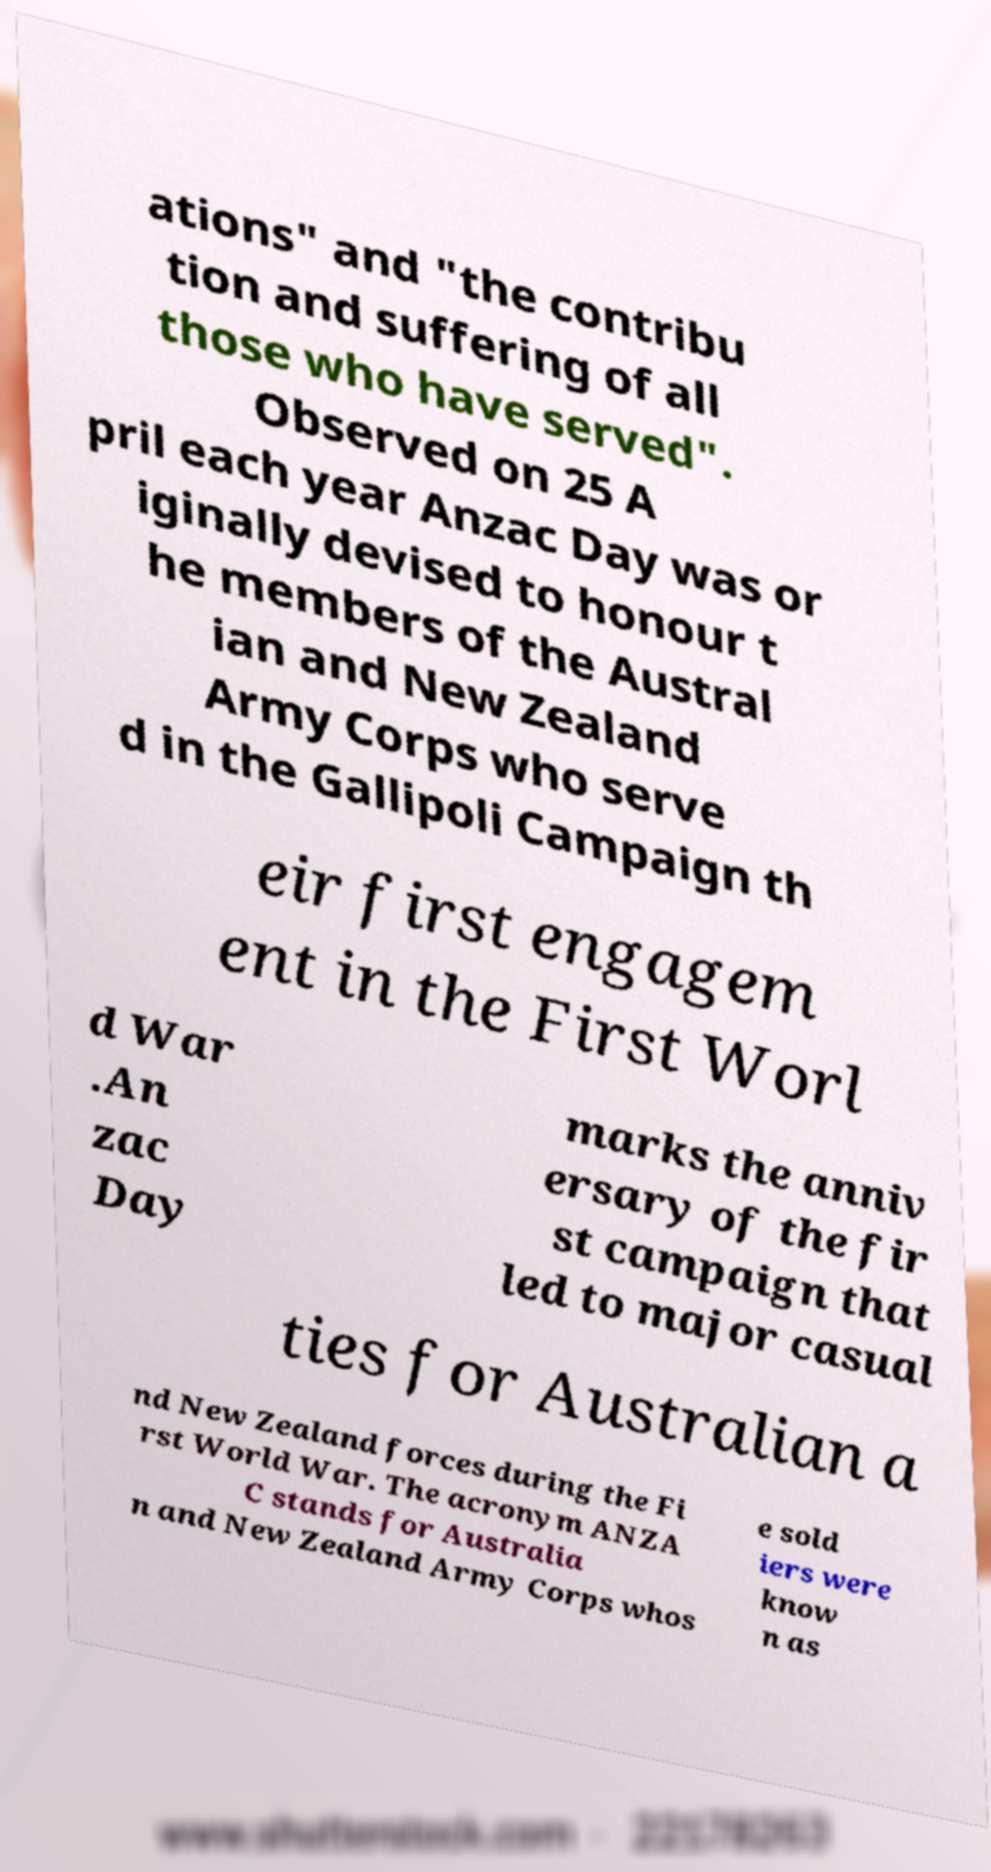What messages or text are displayed in this image? I need them in a readable, typed format. ations" and "the contribu tion and suffering of all those who have served". Observed on 25 A pril each year Anzac Day was or iginally devised to honour t he members of the Austral ian and New Zealand Army Corps who serve d in the Gallipoli Campaign th eir first engagem ent in the First Worl d War .An zac Day marks the anniv ersary of the fir st campaign that led to major casual ties for Australian a nd New Zealand forces during the Fi rst World War. The acronym ANZA C stands for Australia n and New Zealand Army Corps whos e sold iers were know n as 